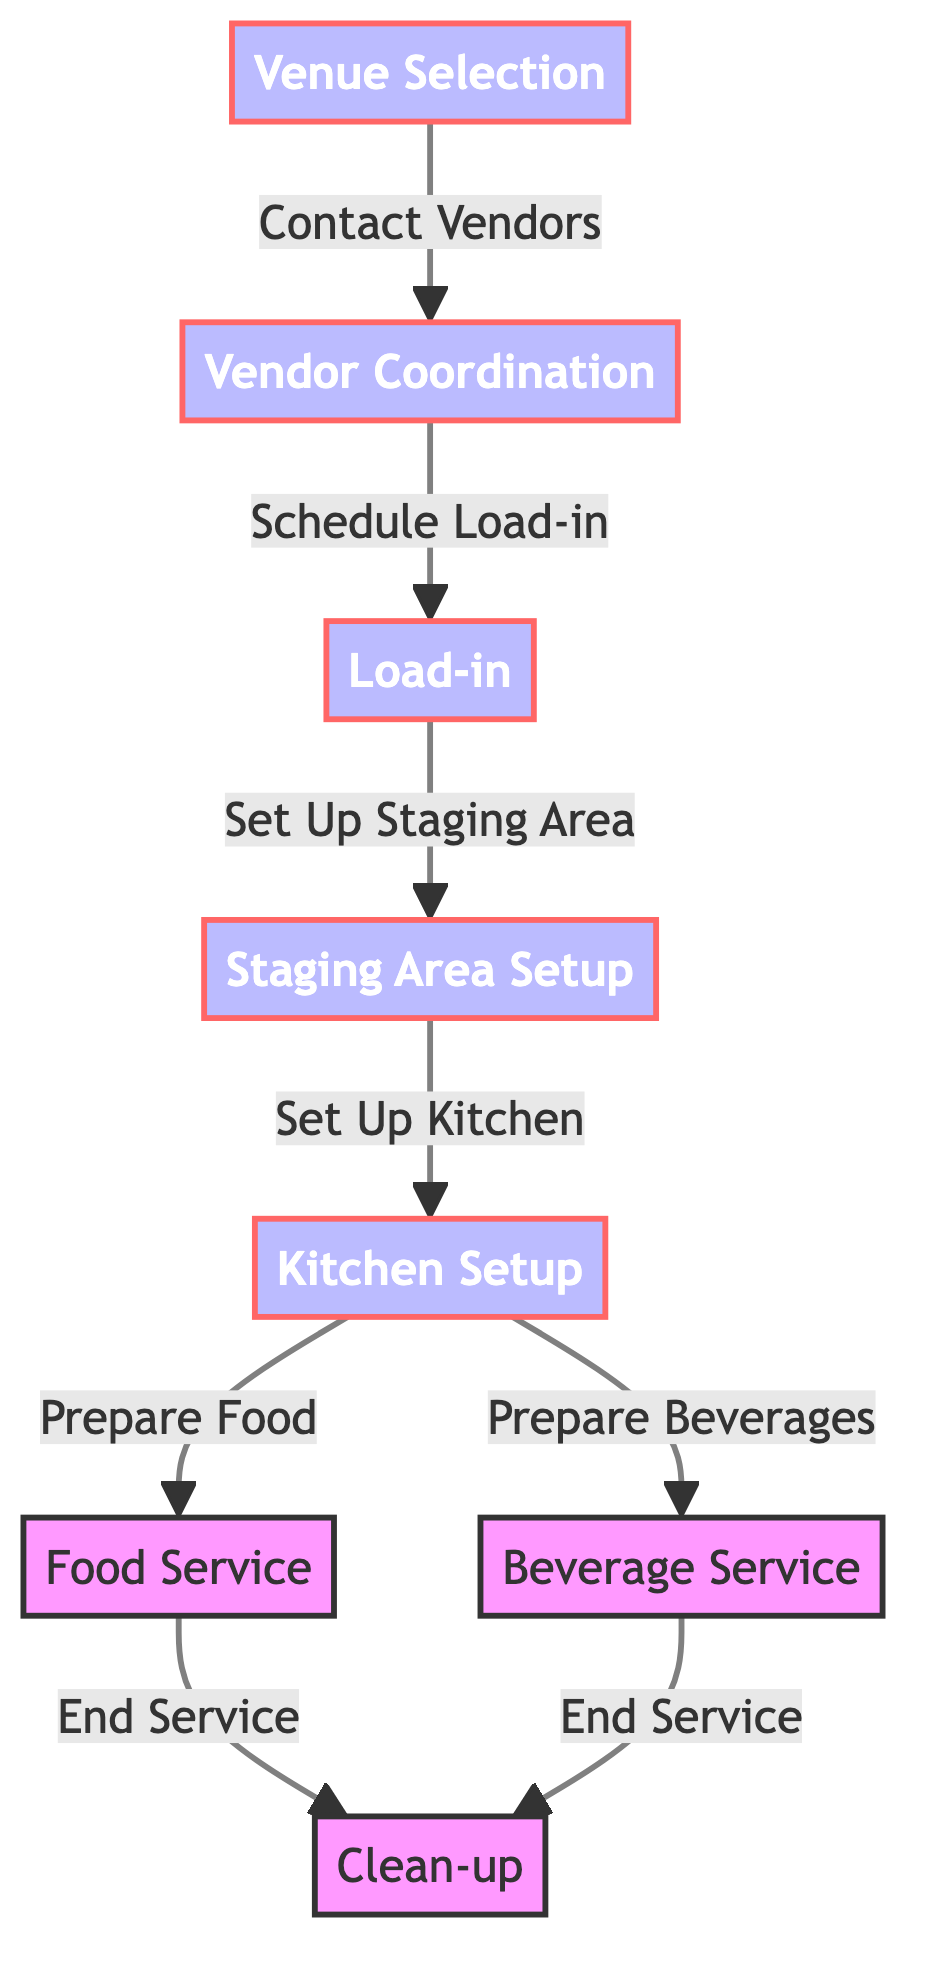What is the first step in the food chain? The diagram shows that the first step is "Venue Selection," as it is the node that starts the process.
Answer: Venue Selection How many main nodes are there in the food chain? There are eight main nodes in the diagram, which include Venue Selection, Vendor Coordination, Load-in, Staging Area Setup, Kitchen Setup, Food Service, Beverage Service, and Clean-up.
Answer: Eight Which step leads to the "Load-in" stage? The step that leads to the Load-in stage is "Vendor Coordination," as indicated by the arrow pointing from Vendor Coordination to Load-in.
Answer: Vendor Coordination What services are prepared during the "Kitchen Setup"? During the Kitchen Setup, Food and Beverages are prepared, as indicated by the arrows pointing from Kitchen Setup to both Food Service and Beverage Service.
Answer: Food and Beverages What happens after the "Food Service" is completed? After Food Service is completed, the next step is "Clean-up," as shown by the arrow pointing from Food Service to Clean-up.
Answer: Clean-up What does "Vendor Coordination" involve? Vendor Coordination involves contacting vendors, which connects it to the next step in the chain, Load-in.
Answer: Contacting vendors What indicates the end of the beverage service? The end of the beverage service is indicated by the arrow leading from Beverage Service to Clean-up, signaling that once beverage service ends, the clean-up process begins.
Answer: Clean-up Which stages are parallel processes in the diagram? The parallel processes in the diagram are "Food Service" and "Beverage Service," as both directly follow Kitchen Setup and lead to Clean-up.
Answer: Food Service and Beverage Service 